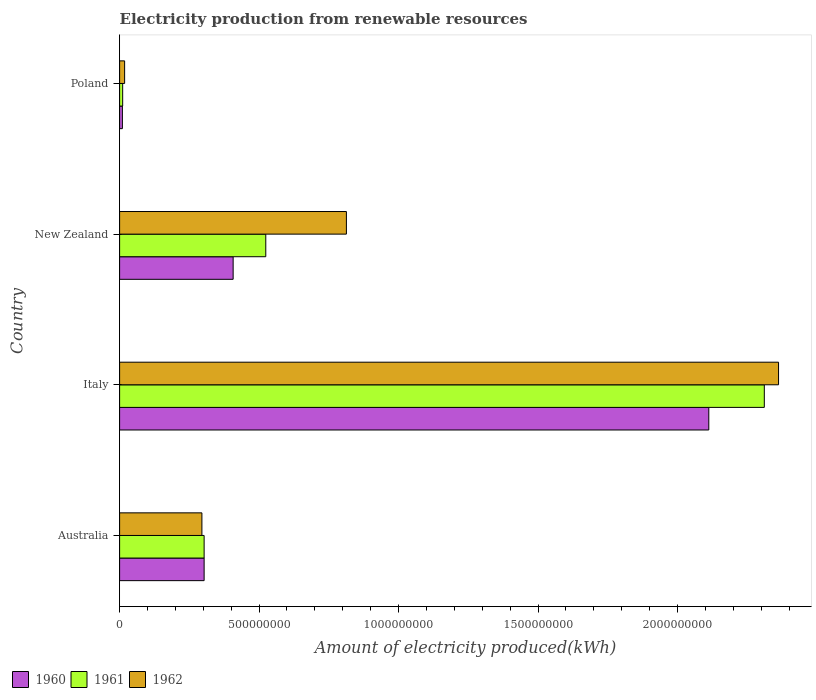How many different coloured bars are there?
Provide a short and direct response. 3. How many groups of bars are there?
Your answer should be very brief. 4. Are the number of bars per tick equal to the number of legend labels?
Make the answer very short. Yes. How many bars are there on the 2nd tick from the top?
Give a very brief answer. 3. What is the label of the 2nd group of bars from the top?
Give a very brief answer. New Zealand. What is the amount of electricity produced in 1960 in Italy?
Offer a terse response. 2.11e+09. Across all countries, what is the maximum amount of electricity produced in 1962?
Provide a short and direct response. 2.36e+09. Across all countries, what is the minimum amount of electricity produced in 1961?
Provide a succinct answer. 1.10e+07. In which country was the amount of electricity produced in 1960 maximum?
Provide a succinct answer. Italy. What is the total amount of electricity produced in 1960 in the graph?
Your response must be concise. 2.83e+09. What is the difference between the amount of electricity produced in 1961 in Australia and that in Italy?
Your answer should be very brief. -2.01e+09. What is the difference between the amount of electricity produced in 1962 in New Zealand and the amount of electricity produced in 1960 in Australia?
Offer a very short reply. 5.10e+08. What is the average amount of electricity produced in 1960 per country?
Ensure brevity in your answer.  7.08e+08. What is the difference between the amount of electricity produced in 1961 and amount of electricity produced in 1962 in Italy?
Keep it short and to the point. -5.10e+07. What is the ratio of the amount of electricity produced in 1961 in Italy to that in New Zealand?
Your answer should be very brief. 4.41. Is the amount of electricity produced in 1961 in New Zealand less than that in Poland?
Ensure brevity in your answer.  No. What is the difference between the highest and the second highest amount of electricity produced in 1960?
Your response must be concise. 1.70e+09. What is the difference between the highest and the lowest amount of electricity produced in 1960?
Keep it short and to the point. 2.10e+09. What does the 3rd bar from the top in Australia represents?
Give a very brief answer. 1960. What does the 1st bar from the bottom in Italy represents?
Your answer should be very brief. 1960. Is it the case that in every country, the sum of the amount of electricity produced in 1962 and amount of electricity produced in 1961 is greater than the amount of electricity produced in 1960?
Keep it short and to the point. Yes. How many bars are there?
Make the answer very short. 12. How many countries are there in the graph?
Make the answer very short. 4. What is the difference between two consecutive major ticks on the X-axis?
Provide a succinct answer. 5.00e+08. Does the graph contain any zero values?
Offer a terse response. No. Where does the legend appear in the graph?
Provide a succinct answer. Bottom left. How many legend labels are there?
Your answer should be compact. 3. How are the legend labels stacked?
Offer a very short reply. Horizontal. What is the title of the graph?
Offer a very short reply. Electricity production from renewable resources. Does "1962" appear as one of the legend labels in the graph?
Give a very brief answer. Yes. What is the label or title of the X-axis?
Make the answer very short. Amount of electricity produced(kWh). What is the Amount of electricity produced(kWh) in 1960 in Australia?
Provide a short and direct response. 3.03e+08. What is the Amount of electricity produced(kWh) of 1961 in Australia?
Offer a terse response. 3.03e+08. What is the Amount of electricity produced(kWh) of 1962 in Australia?
Your response must be concise. 2.95e+08. What is the Amount of electricity produced(kWh) in 1960 in Italy?
Provide a succinct answer. 2.11e+09. What is the Amount of electricity produced(kWh) of 1961 in Italy?
Your answer should be very brief. 2.31e+09. What is the Amount of electricity produced(kWh) of 1962 in Italy?
Give a very brief answer. 2.36e+09. What is the Amount of electricity produced(kWh) in 1960 in New Zealand?
Make the answer very short. 4.07e+08. What is the Amount of electricity produced(kWh) of 1961 in New Zealand?
Provide a succinct answer. 5.24e+08. What is the Amount of electricity produced(kWh) of 1962 in New Zealand?
Your answer should be very brief. 8.13e+08. What is the Amount of electricity produced(kWh) of 1960 in Poland?
Your response must be concise. 1.00e+07. What is the Amount of electricity produced(kWh) of 1961 in Poland?
Give a very brief answer. 1.10e+07. What is the Amount of electricity produced(kWh) of 1962 in Poland?
Your response must be concise. 1.80e+07. Across all countries, what is the maximum Amount of electricity produced(kWh) in 1960?
Your answer should be compact. 2.11e+09. Across all countries, what is the maximum Amount of electricity produced(kWh) of 1961?
Offer a terse response. 2.31e+09. Across all countries, what is the maximum Amount of electricity produced(kWh) in 1962?
Give a very brief answer. 2.36e+09. Across all countries, what is the minimum Amount of electricity produced(kWh) of 1960?
Make the answer very short. 1.00e+07. Across all countries, what is the minimum Amount of electricity produced(kWh) in 1961?
Provide a succinct answer. 1.10e+07. Across all countries, what is the minimum Amount of electricity produced(kWh) of 1962?
Ensure brevity in your answer.  1.80e+07. What is the total Amount of electricity produced(kWh) in 1960 in the graph?
Ensure brevity in your answer.  2.83e+09. What is the total Amount of electricity produced(kWh) in 1961 in the graph?
Your response must be concise. 3.15e+09. What is the total Amount of electricity produced(kWh) in 1962 in the graph?
Keep it short and to the point. 3.49e+09. What is the difference between the Amount of electricity produced(kWh) of 1960 in Australia and that in Italy?
Offer a very short reply. -1.81e+09. What is the difference between the Amount of electricity produced(kWh) of 1961 in Australia and that in Italy?
Ensure brevity in your answer.  -2.01e+09. What is the difference between the Amount of electricity produced(kWh) in 1962 in Australia and that in Italy?
Offer a very short reply. -2.07e+09. What is the difference between the Amount of electricity produced(kWh) in 1960 in Australia and that in New Zealand?
Provide a succinct answer. -1.04e+08. What is the difference between the Amount of electricity produced(kWh) of 1961 in Australia and that in New Zealand?
Offer a terse response. -2.21e+08. What is the difference between the Amount of electricity produced(kWh) of 1962 in Australia and that in New Zealand?
Provide a short and direct response. -5.18e+08. What is the difference between the Amount of electricity produced(kWh) in 1960 in Australia and that in Poland?
Your response must be concise. 2.93e+08. What is the difference between the Amount of electricity produced(kWh) in 1961 in Australia and that in Poland?
Make the answer very short. 2.92e+08. What is the difference between the Amount of electricity produced(kWh) of 1962 in Australia and that in Poland?
Your answer should be compact. 2.77e+08. What is the difference between the Amount of electricity produced(kWh) in 1960 in Italy and that in New Zealand?
Give a very brief answer. 1.70e+09. What is the difference between the Amount of electricity produced(kWh) in 1961 in Italy and that in New Zealand?
Your answer should be very brief. 1.79e+09. What is the difference between the Amount of electricity produced(kWh) of 1962 in Italy and that in New Zealand?
Provide a short and direct response. 1.55e+09. What is the difference between the Amount of electricity produced(kWh) of 1960 in Italy and that in Poland?
Your response must be concise. 2.10e+09. What is the difference between the Amount of electricity produced(kWh) of 1961 in Italy and that in Poland?
Give a very brief answer. 2.30e+09. What is the difference between the Amount of electricity produced(kWh) in 1962 in Italy and that in Poland?
Provide a succinct answer. 2.34e+09. What is the difference between the Amount of electricity produced(kWh) in 1960 in New Zealand and that in Poland?
Your response must be concise. 3.97e+08. What is the difference between the Amount of electricity produced(kWh) in 1961 in New Zealand and that in Poland?
Provide a succinct answer. 5.13e+08. What is the difference between the Amount of electricity produced(kWh) of 1962 in New Zealand and that in Poland?
Offer a terse response. 7.95e+08. What is the difference between the Amount of electricity produced(kWh) of 1960 in Australia and the Amount of electricity produced(kWh) of 1961 in Italy?
Provide a short and direct response. -2.01e+09. What is the difference between the Amount of electricity produced(kWh) of 1960 in Australia and the Amount of electricity produced(kWh) of 1962 in Italy?
Your answer should be very brief. -2.06e+09. What is the difference between the Amount of electricity produced(kWh) in 1961 in Australia and the Amount of electricity produced(kWh) in 1962 in Italy?
Provide a short and direct response. -2.06e+09. What is the difference between the Amount of electricity produced(kWh) of 1960 in Australia and the Amount of electricity produced(kWh) of 1961 in New Zealand?
Give a very brief answer. -2.21e+08. What is the difference between the Amount of electricity produced(kWh) in 1960 in Australia and the Amount of electricity produced(kWh) in 1962 in New Zealand?
Your answer should be compact. -5.10e+08. What is the difference between the Amount of electricity produced(kWh) of 1961 in Australia and the Amount of electricity produced(kWh) of 1962 in New Zealand?
Provide a succinct answer. -5.10e+08. What is the difference between the Amount of electricity produced(kWh) of 1960 in Australia and the Amount of electricity produced(kWh) of 1961 in Poland?
Provide a succinct answer. 2.92e+08. What is the difference between the Amount of electricity produced(kWh) in 1960 in Australia and the Amount of electricity produced(kWh) in 1962 in Poland?
Provide a succinct answer. 2.85e+08. What is the difference between the Amount of electricity produced(kWh) of 1961 in Australia and the Amount of electricity produced(kWh) of 1962 in Poland?
Provide a short and direct response. 2.85e+08. What is the difference between the Amount of electricity produced(kWh) in 1960 in Italy and the Amount of electricity produced(kWh) in 1961 in New Zealand?
Offer a terse response. 1.59e+09. What is the difference between the Amount of electricity produced(kWh) in 1960 in Italy and the Amount of electricity produced(kWh) in 1962 in New Zealand?
Ensure brevity in your answer.  1.30e+09. What is the difference between the Amount of electricity produced(kWh) in 1961 in Italy and the Amount of electricity produced(kWh) in 1962 in New Zealand?
Offer a very short reply. 1.50e+09. What is the difference between the Amount of electricity produced(kWh) in 1960 in Italy and the Amount of electricity produced(kWh) in 1961 in Poland?
Your response must be concise. 2.10e+09. What is the difference between the Amount of electricity produced(kWh) of 1960 in Italy and the Amount of electricity produced(kWh) of 1962 in Poland?
Provide a short and direct response. 2.09e+09. What is the difference between the Amount of electricity produced(kWh) of 1961 in Italy and the Amount of electricity produced(kWh) of 1962 in Poland?
Provide a succinct answer. 2.29e+09. What is the difference between the Amount of electricity produced(kWh) in 1960 in New Zealand and the Amount of electricity produced(kWh) in 1961 in Poland?
Make the answer very short. 3.96e+08. What is the difference between the Amount of electricity produced(kWh) of 1960 in New Zealand and the Amount of electricity produced(kWh) of 1962 in Poland?
Provide a succinct answer. 3.89e+08. What is the difference between the Amount of electricity produced(kWh) in 1961 in New Zealand and the Amount of electricity produced(kWh) in 1962 in Poland?
Offer a terse response. 5.06e+08. What is the average Amount of electricity produced(kWh) in 1960 per country?
Provide a succinct answer. 7.08e+08. What is the average Amount of electricity produced(kWh) of 1961 per country?
Keep it short and to the point. 7.87e+08. What is the average Amount of electricity produced(kWh) in 1962 per country?
Your answer should be compact. 8.72e+08. What is the difference between the Amount of electricity produced(kWh) in 1960 and Amount of electricity produced(kWh) in 1961 in Australia?
Give a very brief answer. 0. What is the difference between the Amount of electricity produced(kWh) in 1960 and Amount of electricity produced(kWh) in 1962 in Australia?
Make the answer very short. 8.00e+06. What is the difference between the Amount of electricity produced(kWh) in 1961 and Amount of electricity produced(kWh) in 1962 in Australia?
Ensure brevity in your answer.  8.00e+06. What is the difference between the Amount of electricity produced(kWh) in 1960 and Amount of electricity produced(kWh) in 1961 in Italy?
Make the answer very short. -1.99e+08. What is the difference between the Amount of electricity produced(kWh) in 1960 and Amount of electricity produced(kWh) in 1962 in Italy?
Your response must be concise. -2.50e+08. What is the difference between the Amount of electricity produced(kWh) in 1961 and Amount of electricity produced(kWh) in 1962 in Italy?
Make the answer very short. -5.10e+07. What is the difference between the Amount of electricity produced(kWh) of 1960 and Amount of electricity produced(kWh) of 1961 in New Zealand?
Give a very brief answer. -1.17e+08. What is the difference between the Amount of electricity produced(kWh) in 1960 and Amount of electricity produced(kWh) in 1962 in New Zealand?
Your answer should be compact. -4.06e+08. What is the difference between the Amount of electricity produced(kWh) of 1961 and Amount of electricity produced(kWh) of 1962 in New Zealand?
Your answer should be compact. -2.89e+08. What is the difference between the Amount of electricity produced(kWh) of 1960 and Amount of electricity produced(kWh) of 1962 in Poland?
Ensure brevity in your answer.  -8.00e+06. What is the difference between the Amount of electricity produced(kWh) in 1961 and Amount of electricity produced(kWh) in 1962 in Poland?
Your answer should be very brief. -7.00e+06. What is the ratio of the Amount of electricity produced(kWh) of 1960 in Australia to that in Italy?
Provide a short and direct response. 0.14. What is the ratio of the Amount of electricity produced(kWh) of 1961 in Australia to that in Italy?
Ensure brevity in your answer.  0.13. What is the ratio of the Amount of electricity produced(kWh) in 1962 in Australia to that in Italy?
Provide a succinct answer. 0.12. What is the ratio of the Amount of electricity produced(kWh) of 1960 in Australia to that in New Zealand?
Offer a terse response. 0.74. What is the ratio of the Amount of electricity produced(kWh) of 1961 in Australia to that in New Zealand?
Your answer should be very brief. 0.58. What is the ratio of the Amount of electricity produced(kWh) in 1962 in Australia to that in New Zealand?
Provide a short and direct response. 0.36. What is the ratio of the Amount of electricity produced(kWh) of 1960 in Australia to that in Poland?
Provide a succinct answer. 30.3. What is the ratio of the Amount of electricity produced(kWh) of 1961 in Australia to that in Poland?
Make the answer very short. 27.55. What is the ratio of the Amount of electricity produced(kWh) of 1962 in Australia to that in Poland?
Provide a succinct answer. 16.39. What is the ratio of the Amount of electricity produced(kWh) of 1960 in Italy to that in New Zealand?
Keep it short and to the point. 5.19. What is the ratio of the Amount of electricity produced(kWh) of 1961 in Italy to that in New Zealand?
Provide a succinct answer. 4.41. What is the ratio of the Amount of electricity produced(kWh) in 1962 in Italy to that in New Zealand?
Your answer should be very brief. 2.91. What is the ratio of the Amount of electricity produced(kWh) of 1960 in Italy to that in Poland?
Your answer should be compact. 211.2. What is the ratio of the Amount of electricity produced(kWh) in 1961 in Italy to that in Poland?
Your answer should be compact. 210.09. What is the ratio of the Amount of electricity produced(kWh) in 1962 in Italy to that in Poland?
Your response must be concise. 131.22. What is the ratio of the Amount of electricity produced(kWh) in 1960 in New Zealand to that in Poland?
Your answer should be very brief. 40.7. What is the ratio of the Amount of electricity produced(kWh) in 1961 in New Zealand to that in Poland?
Your answer should be compact. 47.64. What is the ratio of the Amount of electricity produced(kWh) of 1962 in New Zealand to that in Poland?
Offer a terse response. 45.17. What is the difference between the highest and the second highest Amount of electricity produced(kWh) of 1960?
Provide a succinct answer. 1.70e+09. What is the difference between the highest and the second highest Amount of electricity produced(kWh) in 1961?
Ensure brevity in your answer.  1.79e+09. What is the difference between the highest and the second highest Amount of electricity produced(kWh) in 1962?
Your answer should be very brief. 1.55e+09. What is the difference between the highest and the lowest Amount of electricity produced(kWh) in 1960?
Offer a terse response. 2.10e+09. What is the difference between the highest and the lowest Amount of electricity produced(kWh) in 1961?
Ensure brevity in your answer.  2.30e+09. What is the difference between the highest and the lowest Amount of electricity produced(kWh) of 1962?
Provide a succinct answer. 2.34e+09. 